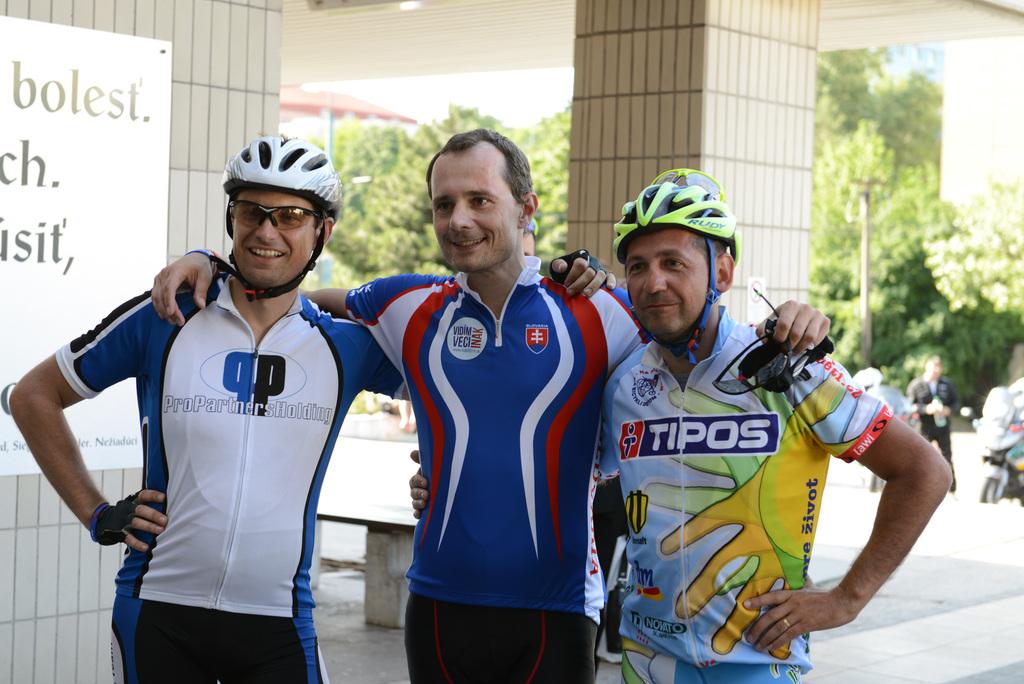What sponsor name is on the guys shirt on the left?
Your answer should be compact. Propartnersholding. 